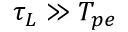Convert formula to latex. <formula><loc_0><loc_0><loc_500><loc_500>\tau _ { L } \gg T _ { p e }</formula> 